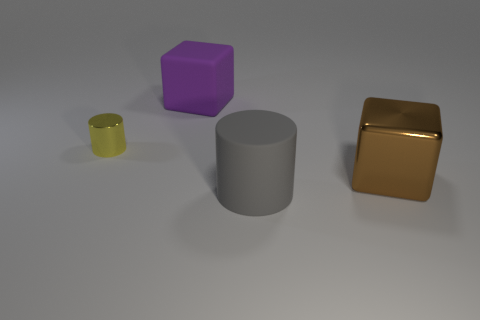Subtract all yellow cylinders. Subtract all cyan spheres. How many cylinders are left? 1 Subtract all cyan cylinders. How many green cubes are left? 0 Add 3 big yellows. How many large browns exist? 0 Subtract all big gray things. Subtract all yellow cylinders. How many objects are left? 2 Add 3 metallic cubes. How many metallic cubes are left? 4 Add 4 green matte blocks. How many green matte blocks exist? 4 Add 3 purple matte objects. How many objects exist? 7 Subtract all purple blocks. How many blocks are left? 1 Subtract 0 red spheres. How many objects are left? 4 Subtract 2 cylinders. How many cylinders are left? 0 